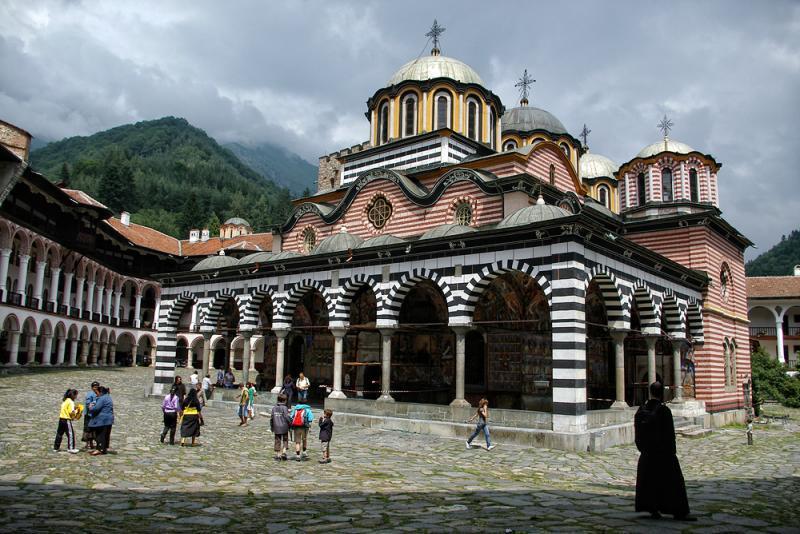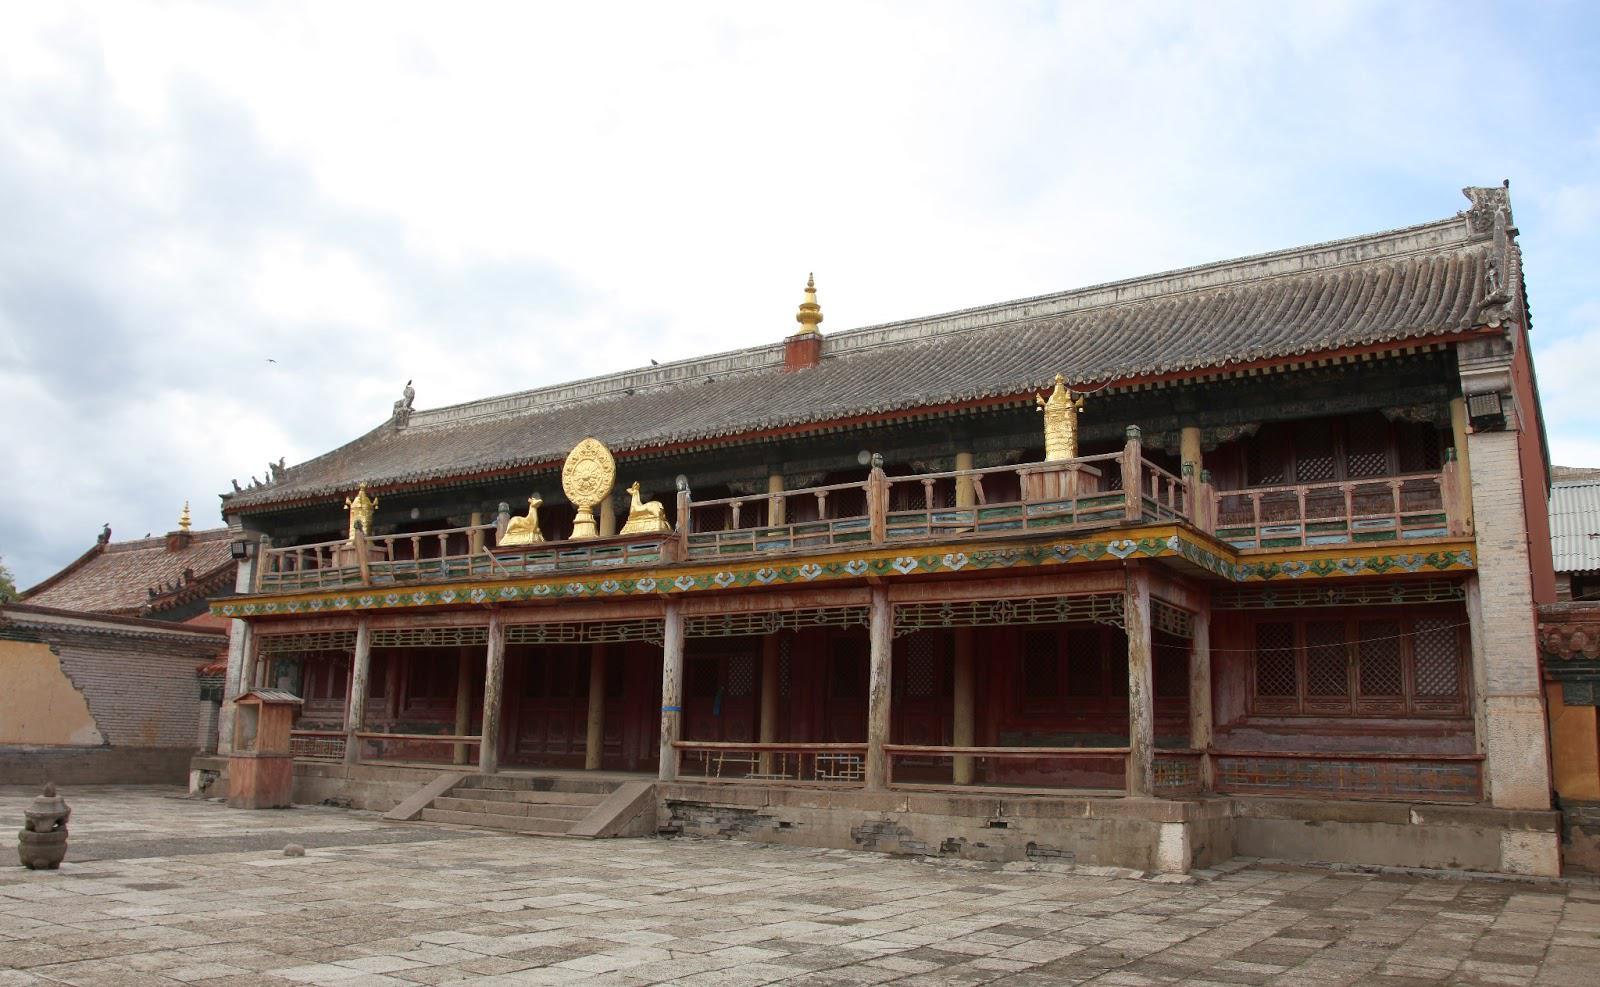The first image is the image on the left, the second image is the image on the right. Examine the images to the left and right. Is the description "Multiple domes topped with crosses are included in one image." accurate? Answer yes or no. Yes. The first image is the image on the left, the second image is the image on the right. Given the left and right images, does the statement "People walk the streets in an historic area." hold true? Answer yes or no. Yes. 